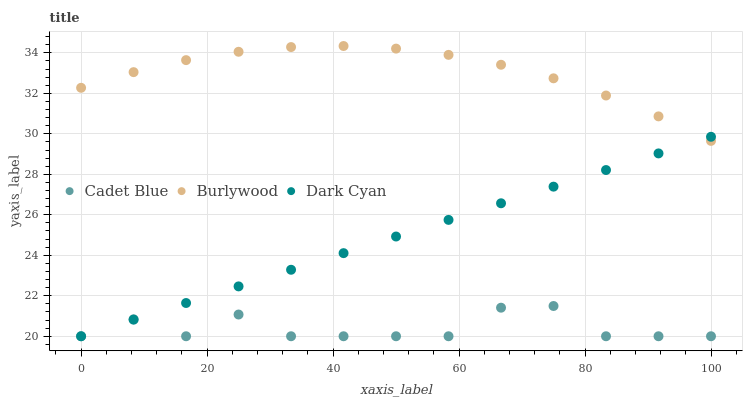Does Cadet Blue have the minimum area under the curve?
Answer yes or no. Yes. Does Burlywood have the maximum area under the curve?
Answer yes or no. Yes. Does Dark Cyan have the minimum area under the curve?
Answer yes or no. No. Does Dark Cyan have the maximum area under the curve?
Answer yes or no. No. Is Dark Cyan the smoothest?
Answer yes or no. Yes. Is Cadet Blue the roughest?
Answer yes or no. Yes. Is Cadet Blue the smoothest?
Answer yes or no. No. Is Dark Cyan the roughest?
Answer yes or no. No. Does Dark Cyan have the lowest value?
Answer yes or no. Yes. Does Burlywood have the highest value?
Answer yes or no. Yes. Does Dark Cyan have the highest value?
Answer yes or no. No. Is Cadet Blue less than Burlywood?
Answer yes or no. Yes. Is Burlywood greater than Cadet Blue?
Answer yes or no. Yes. Does Dark Cyan intersect Burlywood?
Answer yes or no. Yes. Is Dark Cyan less than Burlywood?
Answer yes or no. No. Is Dark Cyan greater than Burlywood?
Answer yes or no. No. Does Cadet Blue intersect Burlywood?
Answer yes or no. No. 